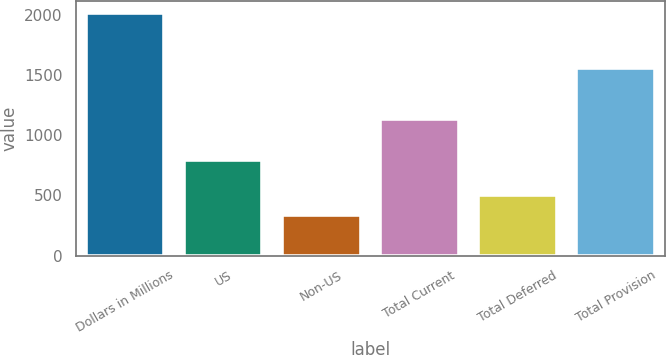Convert chart. <chart><loc_0><loc_0><loc_500><loc_500><bar_chart><fcel>Dollars in Millions<fcel>US<fcel>Non-US<fcel>Total Current<fcel>Total Deferred<fcel>Total Provision<nl><fcel>2010<fcel>797<fcel>339<fcel>1136<fcel>506.1<fcel>1558<nl></chart> 